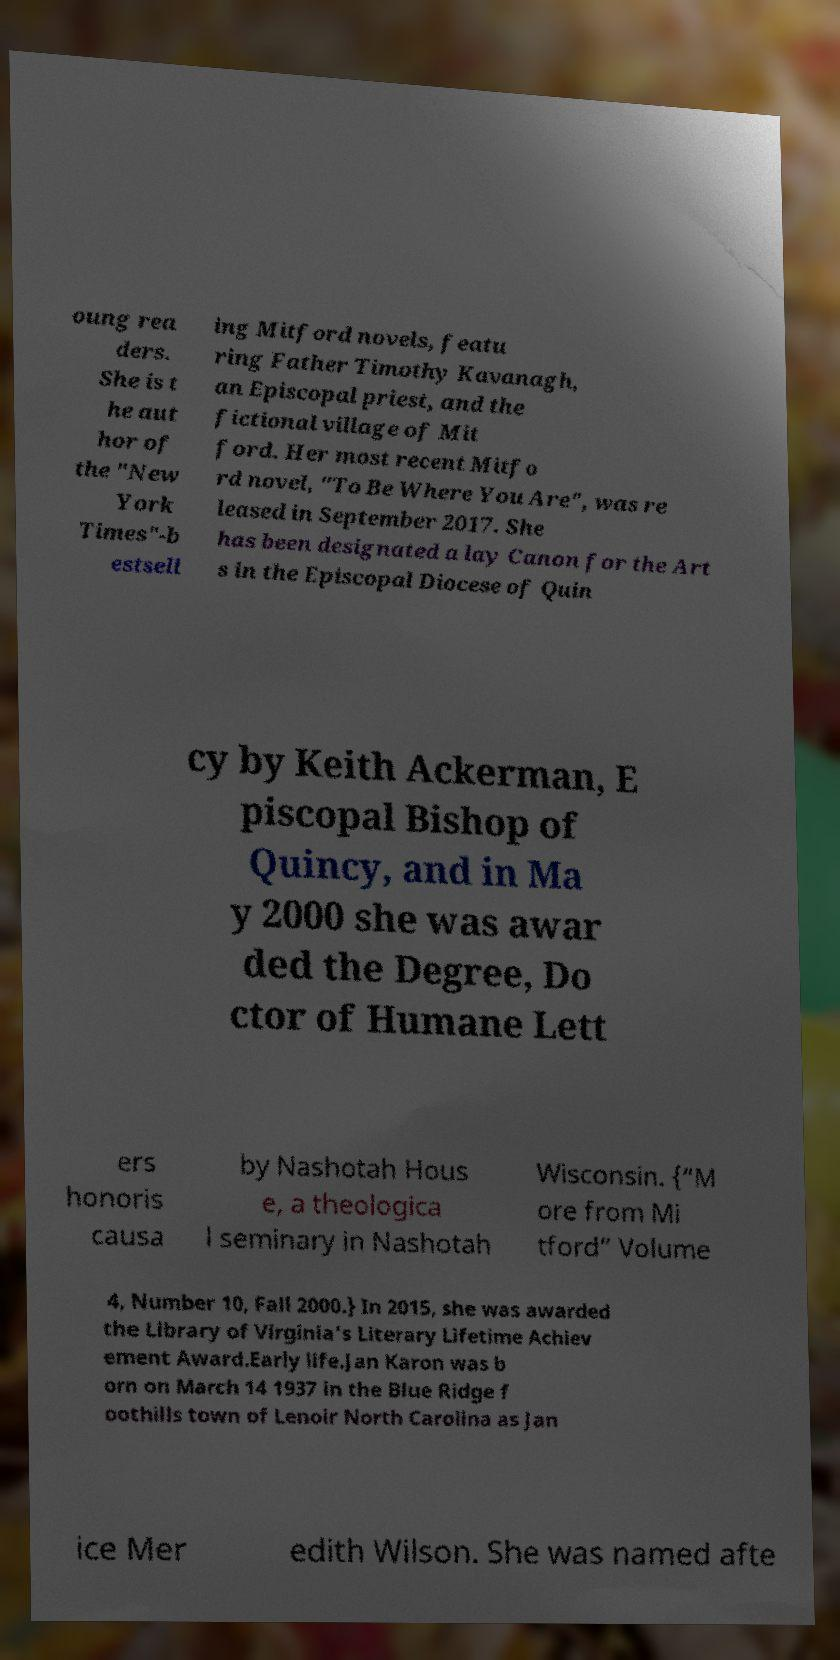Please read and relay the text visible in this image. What does it say? oung rea ders. She is t he aut hor of the "New York Times"-b estsell ing Mitford novels, featu ring Father Timothy Kavanagh, an Episcopal priest, and the fictional village of Mit ford. Her most recent Mitfo rd novel, "To Be Where You Are", was re leased in September 2017. She has been designated a lay Canon for the Art s in the Episcopal Diocese of Quin cy by Keith Ackerman, E piscopal Bishop of Quincy, and in Ma y 2000 she was awar ded the Degree, Do ctor of Humane Lett ers honoris causa by Nashotah Hous e, a theologica l seminary in Nashotah Wisconsin. {“M ore from Mi tford” Volume 4, Number 10, Fall 2000.} In 2015, she was awarded the Library of Virginia's Literary Lifetime Achiev ement Award.Early life.Jan Karon was b orn on March 14 1937 in the Blue Ridge f oothills town of Lenoir North Carolina as Jan ice Mer edith Wilson. She was named afte 